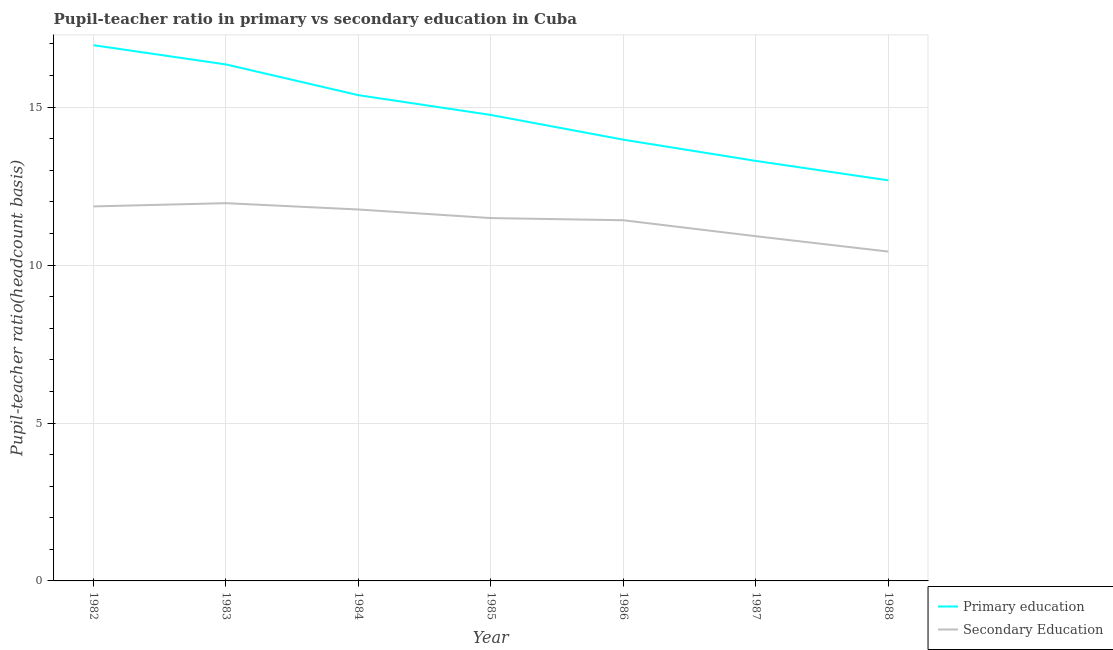How many different coloured lines are there?
Offer a terse response. 2. Does the line corresponding to pupil-teacher ratio in primary education intersect with the line corresponding to pupil teacher ratio on secondary education?
Provide a short and direct response. No. Is the number of lines equal to the number of legend labels?
Your answer should be compact. Yes. What is the pupil-teacher ratio in primary education in 1983?
Offer a terse response. 16.35. Across all years, what is the maximum pupil-teacher ratio in primary education?
Offer a terse response. 16.96. Across all years, what is the minimum pupil-teacher ratio in primary education?
Ensure brevity in your answer.  12.68. In which year was the pupil-teacher ratio in primary education minimum?
Offer a very short reply. 1988. What is the total pupil teacher ratio on secondary education in the graph?
Make the answer very short. 79.83. What is the difference between the pupil teacher ratio on secondary education in 1982 and that in 1985?
Your response must be concise. 0.37. What is the difference between the pupil teacher ratio on secondary education in 1982 and the pupil-teacher ratio in primary education in 1985?
Make the answer very short. -2.89. What is the average pupil-teacher ratio in primary education per year?
Your response must be concise. 14.77. In the year 1982, what is the difference between the pupil-teacher ratio in primary education and pupil teacher ratio on secondary education?
Offer a terse response. 5.1. In how many years, is the pupil-teacher ratio in primary education greater than 4?
Your answer should be compact. 7. What is the ratio of the pupil-teacher ratio in primary education in 1983 to that in 1985?
Provide a succinct answer. 1.11. Is the pupil-teacher ratio in primary education in 1982 less than that in 1987?
Offer a very short reply. No. Is the difference between the pupil teacher ratio on secondary education in 1983 and 1988 greater than the difference between the pupil-teacher ratio in primary education in 1983 and 1988?
Make the answer very short. No. What is the difference between the highest and the second highest pupil teacher ratio on secondary education?
Your response must be concise. 0.1. What is the difference between the highest and the lowest pupil teacher ratio on secondary education?
Offer a very short reply. 1.53. Is the pupil-teacher ratio in primary education strictly greater than the pupil teacher ratio on secondary education over the years?
Your answer should be compact. Yes. Is the pupil-teacher ratio in primary education strictly less than the pupil teacher ratio on secondary education over the years?
Provide a succinct answer. No. How many lines are there?
Your response must be concise. 2. Does the graph contain any zero values?
Ensure brevity in your answer.  No. How many legend labels are there?
Provide a succinct answer. 2. How are the legend labels stacked?
Your answer should be compact. Vertical. What is the title of the graph?
Offer a terse response. Pupil-teacher ratio in primary vs secondary education in Cuba. Does "Sanitation services" appear as one of the legend labels in the graph?
Make the answer very short. No. What is the label or title of the X-axis?
Your answer should be compact. Year. What is the label or title of the Y-axis?
Provide a short and direct response. Pupil-teacher ratio(headcount basis). What is the Pupil-teacher ratio(headcount basis) in Primary education in 1982?
Offer a very short reply. 16.96. What is the Pupil-teacher ratio(headcount basis) in Secondary Education in 1982?
Offer a very short reply. 11.86. What is the Pupil-teacher ratio(headcount basis) of Primary education in 1983?
Give a very brief answer. 16.35. What is the Pupil-teacher ratio(headcount basis) of Secondary Education in 1983?
Ensure brevity in your answer.  11.96. What is the Pupil-teacher ratio(headcount basis) in Primary education in 1984?
Give a very brief answer. 15.38. What is the Pupil-teacher ratio(headcount basis) of Secondary Education in 1984?
Provide a short and direct response. 11.76. What is the Pupil-teacher ratio(headcount basis) of Primary education in 1985?
Provide a succinct answer. 14.75. What is the Pupil-teacher ratio(headcount basis) in Secondary Education in 1985?
Offer a very short reply. 11.49. What is the Pupil-teacher ratio(headcount basis) in Primary education in 1986?
Your answer should be compact. 13.97. What is the Pupil-teacher ratio(headcount basis) in Secondary Education in 1986?
Keep it short and to the point. 11.42. What is the Pupil-teacher ratio(headcount basis) in Primary education in 1987?
Your response must be concise. 13.3. What is the Pupil-teacher ratio(headcount basis) in Secondary Education in 1987?
Your answer should be compact. 10.91. What is the Pupil-teacher ratio(headcount basis) in Primary education in 1988?
Your answer should be very brief. 12.68. What is the Pupil-teacher ratio(headcount basis) in Secondary Education in 1988?
Make the answer very short. 10.43. Across all years, what is the maximum Pupil-teacher ratio(headcount basis) in Primary education?
Offer a terse response. 16.96. Across all years, what is the maximum Pupil-teacher ratio(headcount basis) in Secondary Education?
Ensure brevity in your answer.  11.96. Across all years, what is the minimum Pupil-teacher ratio(headcount basis) in Primary education?
Keep it short and to the point. 12.68. Across all years, what is the minimum Pupil-teacher ratio(headcount basis) of Secondary Education?
Keep it short and to the point. 10.43. What is the total Pupil-teacher ratio(headcount basis) of Primary education in the graph?
Your response must be concise. 103.4. What is the total Pupil-teacher ratio(headcount basis) of Secondary Education in the graph?
Your answer should be compact. 79.83. What is the difference between the Pupil-teacher ratio(headcount basis) of Primary education in 1982 and that in 1983?
Make the answer very short. 0.61. What is the difference between the Pupil-teacher ratio(headcount basis) of Secondary Education in 1982 and that in 1983?
Ensure brevity in your answer.  -0.1. What is the difference between the Pupil-teacher ratio(headcount basis) of Primary education in 1982 and that in 1984?
Make the answer very short. 1.58. What is the difference between the Pupil-teacher ratio(headcount basis) in Secondary Education in 1982 and that in 1984?
Keep it short and to the point. 0.1. What is the difference between the Pupil-teacher ratio(headcount basis) of Primary education in 1982 and that in 1985?
Your response must be concise. 2.21. What is the difference between the Pupil-teacher ratio(headcount basis) in Secondary Education in 1982 and that in 1985?
Offer a very short reply. 0.37. What is the difference between the Pupil-teacher ratio(headcount basis) in Primary education in 1982 and that in 1986?
Give a very brief answer. 2.99. What is the difference between the Pupil-teacher ratio(headcount basis) in Secondary Education in 1982 and that in 1986?
Ensure brevity in your answer.  0.44. What is the difference between the Pupil-teacher ratio(headcount basis) in Primary education in 1982 and that in 1987?
Your answer should be very brief. 3.66. What is the difference between the Pupil-teacher ratio(headcount basis) of Secondary Education in 1982 and that in 1987?
Your response must be concise. 0.94. What is the difference between the Pupil-teacher ratio(headcount basis) in Primary education in 1982 and that in 1988?
Offer a very short reply. 4.28. What is the difference between the Pupil-teacher ratio(headcount basis) of Secondary Education in 1982 and that in 1988?
Your response must be concise. 1.43. What is the difference between the Pupil-teacher ratio(headcount basis) of Primary education in 1983 and that in 1984?
Offer a very short reply. 0.97. What is the difference between the Pupil-teacher ratio(headcount basis) in Secondary Education in 1983 and that in 1984?
Your response must be concise. 0.2. What is the difference between the Pupil-teacher ratio(headcount basis) in Primary education in 1983 and that in 1985?
Offer a terse response. 1.6. What is the difference between the Pupil-teacher ratio(headcount basis) of Secondary Education in 1983 and that in 1985?
Your answer should be very brief. 0.47. What is the difference between the Pupil-teacher ratio(headcount basis) in Primary education in 1983 and that in 1986?
Ensure brevity in your answer.  2.38. What is the difference between the Pupil-teacher ratio(headcount basis) in Secondary Education in 1983 and that in 1986?
Give a very brief answer. 0.54. What is the difference between the Pupil-teacher ratio(headcount basis) in Primary education in 1983 and that in 1987?
Ensure brevity in your answer.  3.05. What is the difference between the Pupil-teacher ratio(headcount basis) in Secondary Education in 1983 and that in 1987?
Give a very brief answer. 1.05. What is the difference between the Pupil-teacher ratio(headcount basis) of Primary education in 1983 and that in 1988?
Your response must be concise. 3.67. What is the difference between the Pupil-teacher ratio(headcount basis) in Secondary Education in 1983 and that in 1988?
Ensure brevity in your answer.  1.53. What is the difference between the Pupil-teacher ratio(headcount basis) of Primary education in 1984 and that in 1985?
Provide a succinct answer. 0.63. What is the difference between the Pupil-teacher ratio(headcount basis) of Secondary Education in 1984 and that in 1985?
Your response must be concise. 0.27. What is the difference between the Pupil-teacher ratio(headcount basis) of Primary education in 1984 and that in 1986?
Keep it short and to the point. 1.41. What is the difference between the Pupil-teacher ratio(headcount basis) in Secondary Education in 1984 and that in 1986?
Give a very brief answer. 0.34. What is the difference between the Pupil-teacher ratio(headcount basis) in Primary education in 1984 and that in 1987?
Your answer should be very brief. 2.08. What is the difference between the Pupil-teacher ratio(headcount basis) in Secondary Education in 1984 and that in 1987?
Provide a short and direct response. 0.85. What is the difference between the Pupil-teacher ratio(headcount basis) in Primary education in 1984 and that in 1988?
Your response must be concise. 2.7. What is the difference between the Pupil-teacher ratio(headcount basis) of Secondary Education in 1984 and that in 1988?
Your answer should be very brief. 1.33. What is the difference between the Pupil-teacher ratio(headcount basis) of Primary education in 1985 and that in 1986?
Provide a succinct answer. 0.78. What is the difference between the Pupil-teacher ratio(headcount basis) of Secondary Education in 1985 and that in 1986?
Your response must be concise. 0.07. What is the difference between the Pupil-teacher ratio(headcount basis) of Primary education in 1985 and that in 1987?
Make the answer very short. 1.45. What is the difference between the Pupil-teacher ratio(headcount basis) of Secondary Education in 1985 and that in 1987?
Give a very brief answer. 0.57. What is the difference between the Pupil-teacher ratio(headcount basis) in Primary education in 1985 and that in 1988?
Your answer should be very brief. 2.07. What is the difference between the Pupil-teacher ratio(headcount basis) in Secondary Education in 1985 and that in 1988?
Your answer should be compact. 1.06. What is the difference between the Pupil-teacher ratio(headcount basis) in Primary education in 1986 and that in 1987?
Provide a succinct answer. 0.67. What is the difference between the Pupil-teacher ratio(headcount basis) in Secondary Education in 1986 and that in 1987?
Ensure brevity in your answer.  0.51. What is the difference between the Pupil-teacher ratio(headcount basis) of Primary education in 1986 and that in 1988?
Your answer should be very brief. 1.29. What is the difference between the Pupil-teacher ratio(headcount basis) of Primary education in 1987 and that in 1988?
Provide a short and direct response. 0.62. What is the difference between the Pupil-teacher ratio(headcount basis) of Secondary Education in 1987 and that in 1988?
Ensure brevity in your answer.  0.49. What is the difference between the Pupil-teacher ratio(headcount basis) of Primary education in 1982 and the Pupil-teacher ratio(headcount basis) of Secondary Education in 1983?
Offer a terse response. 5. What is the difference between the Pupil-teacher ratio(headcount basis) in Primary education in 1982 and the Pupil-teacher ratio(headcount basis) in Secondary Education in 1984?
Make the answer very short. 5.2. What is the difference between the Pupil-teacher ratio(headcount basis) in Primary education in 1982 and the Pupil-teacher ratio(headcount basis) in Secondary Education in 1985?
Provide a short and direct response. 5.47. What is the difference between the Pupil-teacher ratio(headcount basis) in Primary education in 1982 and the Pupil-teacher ratio(headcount basis) in Secondary Education in 1986?
Your answer should be compact. 5.54. What is the difference between the Pupil-teacher ratio(headcount basis) in Primary education in 1982 and the Pupil-teacher ratio(headcount basis) in Secondary Education in 1987?
Make the answer very short. 6.05. What is the difference between the Pupil-teacher ratio(headcount basis) in Primary education in 1982 and the Pupil-teacher ratio(headcount basis) in Secondary Education in 1988?
Give a very brief answer. 6.53. What is the difference between the Pupil-teacher ratio(headcount basis) of Primary education in 1983 and the Pupil-teacher ratio(headcount basis) of Secondary Education in 1984?
Your response must be concise. 4.59. What is the difference between the Pupil-teacher ratio(headcount basis) in Primary education in 1983 and the Pupil-teacher ratio(headcount basis) in Secondary Education in 1985?
Provide a succinct answer. 4.86. What is the difference between the Pupil-teacher ratio(headcount basis) of Primary education in 1983 and the Pupil-teacher ratio(headcount basis) of Secondary Education in 1986?
Offer a very short reply. 4.93. What is the difference between the Pupil-teacher ratio(headcount basis) of Primary education in 1983 and the Pupil-teacher ratio(headcount basis) of Secondary Education in 1987?
Make the answer very short. 5.44. What is the difference between the Pupil-teacher ratio(headcount basis) in Primary education in 1983 and the Pupil-teacher ratio(headcount basis) in Secondary Education in 1988?
Make the answer very short. 5.92. What is the difference between the Pupil-teacher ratio(headcount basis) in Primary education in 1984 and the Pupil-teacher ratio(headcount basis) in Secondary Education in 1985?
Your answer should be compact. 3.89. What is the difference between the Pupil-teacher ratio(headcount basis) in Primary education in 1984 and the Pupil-teacher ratio(headcount basis) in Secondary Education in 1986?
Provide a succinct answer. 3.96. What is the difference between the Pupil-teacher ratio(headcount basis) of Primary education in 1984 and the Pupil-teacher ratio(headcount basis) of Secondary Education in 1987?
Ensure brevity in your answer.  4.47. What is the difference between the Pupil-teacher ratio(headcount basis) in Primary education in 1984 and the Pupil-teacher ratio(headcount basis) in Secondary Education in 1988?
Provide a succinct answer. 4.95. What is the difference between the Pupil-teacher ratio(headcount basis) of Primary education in 1985 and the Pupil-teacher ratio(headcount basis) of Secondary Education in 1986?
Ensure brevity in your answer.  3.33. What is the difference between the Pupil-teacher ratio(headcount basis) of Primary education in 1985 and the Pupil-teacher ratio(headcount basis) of Secondary Education in 1987?
Your response must be concise. 3.84. What is the difference between the Pupil-teacher ratio(headcount basis) of Primary education in 1985 and the Pupil-teacher ratio(headcount basis) of Secondary Education in 1988?
Your response must be concise. 4.32. What is the difference between the Pupil-teacher ratio(headcount basis) of Primary education in 1986 and the Pupil-teacher ratio(headcount basis) of Secondary Education in 1987?
Your answer should be compact. 3.06. What is the difference between the Pupil-teacher ratio(headcount basis) in Primary education in 1986 and the Pupil-teacher ratio(headcount basis) in Secondary Education in 1988?
Make the answer very short. 3.54. What is the difference between the Pupil-teacher ratio(headcount basis) of Primary education in 1987 and the Pupil-teacher ratio(headcount basis) of Secondary Education in 1988?
Your answer should be compact. 2.87. What is the average Pupil-teacher ratio(headcount basis) of Primary education per year?
Offer a very short reply. 14.77. What is the average Pupil-teacher ratio(headcount basis) of Secondary Education per year?
Make the answer very short. 11.4. In the year 1982, what is the difference between the Pupil-teacher ratio(headcount basis) in Primary education and Pupil-teacher ratio(headcount basis) in Secondary Education?
Offer a very short reply. 5.1. In the year 1983, what is the difference between the Pupil-teacher ratio(headcount basis) in Primary education and Pupil-teacher ratio(headcount basis) in Secondary Education?
Your answer should be compact. 4.39. In the year 1984, what is the difference between the Pupil-teacher ratio(headcount basis) of Primary education and Pupil-teacher ratio(headcount basis) of Secondary Education?
Provide a succinct answer. 3.62. In the year 1985, what is the difference between the Pupil-teacher ratio(headcount basis) in Primary education and Pupil-teacher ratio(headcount basis) in Secondary Education?
Offer a very short reply. 3.26. In the year 1986, what is the difference between the Pupil-teacher ratio(headcount basis) of Primary education and Pupil-teacher ratio(headcount basis) of Secondary Education?
Give a very brief answer. 2.55. In the year 1987, what is the difference between the Pupil-teacher ratio(headcount basis) in Primary education and Pupil-teacher ratio(headcount basis) in Secondary Education?
Give a very brief answer. 2.38. In the year 1988, what is the difference between the Pupil-teacher ratio(headcount basis) in Primary education and Pupil-teacher ratio(headcount basis) in Secondary Education?
Ensure brevity in your answer.  2.25. What is the ratio of the Pupil-teacher ratio(headcount basis) of Primary education in 1982 to that in 1983?
Ensure brevity in your answer.  1.04. What is the ratio of the Pupil-teacher ratio(headcount basis) of Primary education in 1982 to that in 1984?
Give a very brief answer. 1.1. What is the ratio of the Pupil-teacher ratio(headcount basis) of Secondary Education in 1982 to that in 1984?
Provide a succinct answer. 1.01. What is the ratio of the Pupil-teacher ratio(headcount basis) in Primary education in 1982 to that in 1985?
Your answer should be compact. 1.15. What is the ratio of the Pupil-teacher ratio(headcount basis) of Secondary Education in 1982 to that in 1985?
Provide a short and direct response. 1.03. What is the ratio of the Pupil-teacher ratio(headcount basis) in Primary education in 1982 to that in 1986?
Provide a short and direct response. 1.21. What is the ratio of the Pupil-teacher ratio(headcount basis) in Secondary Education in 1982 to that in 1986?
Offer a terse response. 1.04. What is the ratio of the Pupil-teacher ratio(headcount basis) of Primary education in 1982 to that in 1987?
Ensure brevity in your answer.  1.28. What is the ratio of the Pupil-teacher ratio(headcount basis) of Secondary Education in 1982 to that in 1987?
Provide a short and direct response. 1.09. What is the ratio of the Pupil-teacher ratio(headcount basis) in Primary education in 1982 to that in 1988?
Your answer should be compact. 1.34. What is the ratio of the Pupil-teacher ratio(headcount basis) in Secondary Education in 1982 to that in 1988?
Keep it short and to the point. 1.14. What is the ratio of the Pupil-teacher ratio(headcount basis) in Primary education in 1983 to that in 1984?
Your answer should be very brief. 1.06. What is the ratio of the Pupil-teacher ratio(headcount basis) in Secondary Education in 1983 to that in 1984?
Ensure brevity in your answer.  1.02. What is the ratio of the Pupil-teacher ratio(headcount basis) of Primary education in 1983 to that in 1985?
Provide a short and direct response. 1.11. What is the ratio of the Pupil-teacher ratio(headcount basis) of Secondary Education in 1983 to that in 1985?
Your response must be concise. 1.04. What is the ratio of the Pupil-teacher ratio(headcount basis) of Primary education in 1983 to that in 1986?
Your answer should be very brief. 1.17. What is the ratio of the Pupil-teacher ratio(headcount basis) of Secondary Education in 1983 to that in 1986?
Offer a terse response. 1.05. What is the ratio of the Pupil-teacher ratio(headcount basis) in Primary education in 1983 to that in 1987?
Ensure brevity in your answer.  1.23. What is the ratio of the Pupil-teacher ratio(headcount basis) in Secondary Education in 1983 to that in 1987?
Provide a short and direct response. 1.1. What is the ratio of the Pupil-teacher ratio(headcount basis) of Primary education in 1983 to that in 1988?
Ensure brevity in your answer.  1.29. What is the ratio of the Pupil-teacher ratio(headcount basis) of Secondary Education in 1983 to that in 1988?
Make the answer very short. 1.15. What is the ratio of the Pupil-teacher ratio(headcount basis) of Primary education in 1984 to that in 1985?
Provide a succinct answer. 1.04. What is the ratio of the Pupil-teacher ratio(headcount basis) of Secondary Education in 1984 to that in 1985?
Provide a succinct answer. 1.02. What is the ratio of the Pupil-teacher ratio(headcount basis) in Primary education in 1984 to that in 1986?
Offer a terse response. 1.1. What is the ratio of the Pupil-teacher ratio(headcount basis) of Secondary Education in 1984 to that in 1986?
Provide a succinct answer. 1.03. What is the ratio of the Pupil-teacher ratio(headcount basis) of Primary education in 1984 to that in 1987?
Keep it short and to the point. 1.16. What is the ratio of the Pupil-teacher ratio(headcount basis) of Secondary Education in 1984 to that in 1987?
Offer a very short reply. 1.08. What is the ratio of the Pupil-teacher ratio(headcount basis) in Primary education in 1984 to that in 1988?
Your answer should be very brief. 1.21. What is the ratio of the Pupil-teacher ratio(headcount basis) in Secondary Education in 1984 to that in 1988?
Give a very brief answer. 1.13. What is the ratio of the Pupil-teacher ratio(headcount basis) in Primary education in 1985 to that in 1986?
Make the answer very short. 1.06. What is the ratio of the Pupil-teacher ratio(headcount basis) in Secondary Education in 1985 to that in 1986?
Give a very brief answer. 1.01. What is the ratio of the Pupil-teacher ratio(headcount basis) of Primary education in 1985 to that in 1987?
Keep it short and to the point. 1.11. What is the ratio of the Pupil-teacher ratio(headcount basis) of Secondary Education in 1985 to that in 1987?
Ensure brevity in your answer.  1.05. What is the ratio of the Pupil-teacher ratio(headcount basis) of Primary education in 1985 to that in 1988?
Provide a succinct answer. 1.16. What is the ratio of the Pupil-teacher ratio(headcount basis) in Secondary Education in 1985 to that in 1988?
Your answer should be very brief. 1.1. What is the ratio of the Pupil-teacher ratio(headcount basis) in Primary education in 1986 to that in 1987?
Make the answer very short. 1.05. What is the ratio of the Pupil-teacher ratio(headcount basis) in Secondary Education in 1986 to that in 1987?
Provide a short and direct response. 1.05. What is the ratio of the Pupil-teacher ratio(headcount basis) in Primary education in 1986 to that in 1988?
Provide a short and direct response. 1.1. What is the ratio of the Pupil-teacher ratio(headcount basis) of Secondary Education in 1986 to that in 1988?
Ensure brevity in your answer.  1.1. What is the ratio of the Pupil-teacher ratio(headcount basis) in Primary education in 1987 to that in 1988?
Provide a short and direct response. 1.05. What is the ratio of the Pupil-teacher ratio(headcount basis) of Secondary Education in 1987 to that in 1988?
Offer a terse response. 1.05. What is the difference between the highest and the second highest Pupil-teacher ratio(headcount basis) in Primary education?
Provide a succinct answer. 0.61. What is the difference between the highest and the second highest Pupil-teacher ratio(headcount basis) of Secondary Education?
Make the answer very short. 0.1. What is the difference between the highest and the lowest Pupil-teacher ratio(headcount basis) of Primary education?
Your answer should be very brief. 4.28. What is the difference between the highest and the lowest Pupil-teacher ratio(headcount basis) in Secondary Education?
Your answer should be very brief. 1.53. 